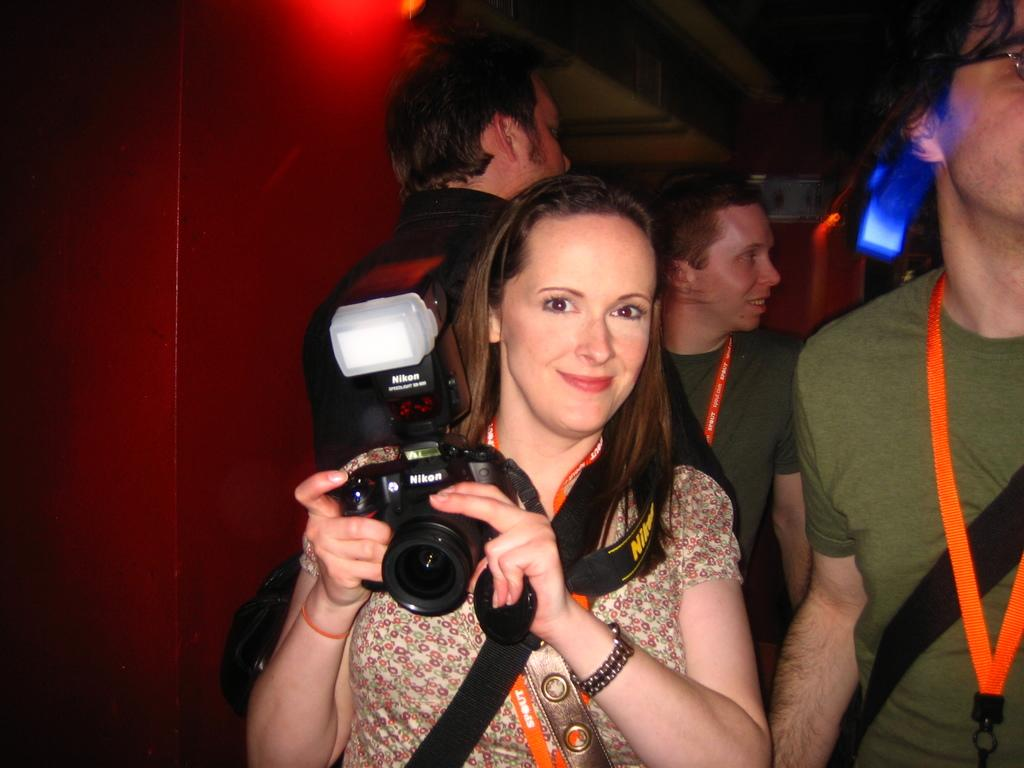Who is the main subject in the image? There is a woman in the center of the image. What is the woman holding in the image? The woman is holding a camera. What is the woman's facial expression in the image? The woman is smiling. How many other people are present in the image? There are three more persons in the background of the image. What type of disgust can be seen on the woman's face in the image? There is no disgust visible on the woman's face in the image; she is smiling. How many nails are visible in the image? There are no nails present in the image. 